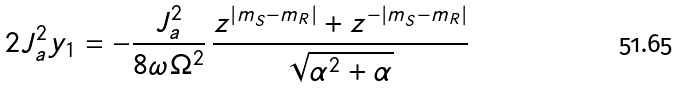<formula> <loc_0><loc_0><loc_500><loc_500>2 J _ { a } ^ { 2 } y _ { 1 } = - \frac { J _ { a } ^ { 2 } } { 8 \omega \Omega ^ { 2 } } \, \frac { z ^ { | m _ { S } - m _ { R } | } + z ^ { - | m _ { S } - m _ { R } | } } { \sqrt { \alpha ^ { 2 } + \alpha } }</formula> 